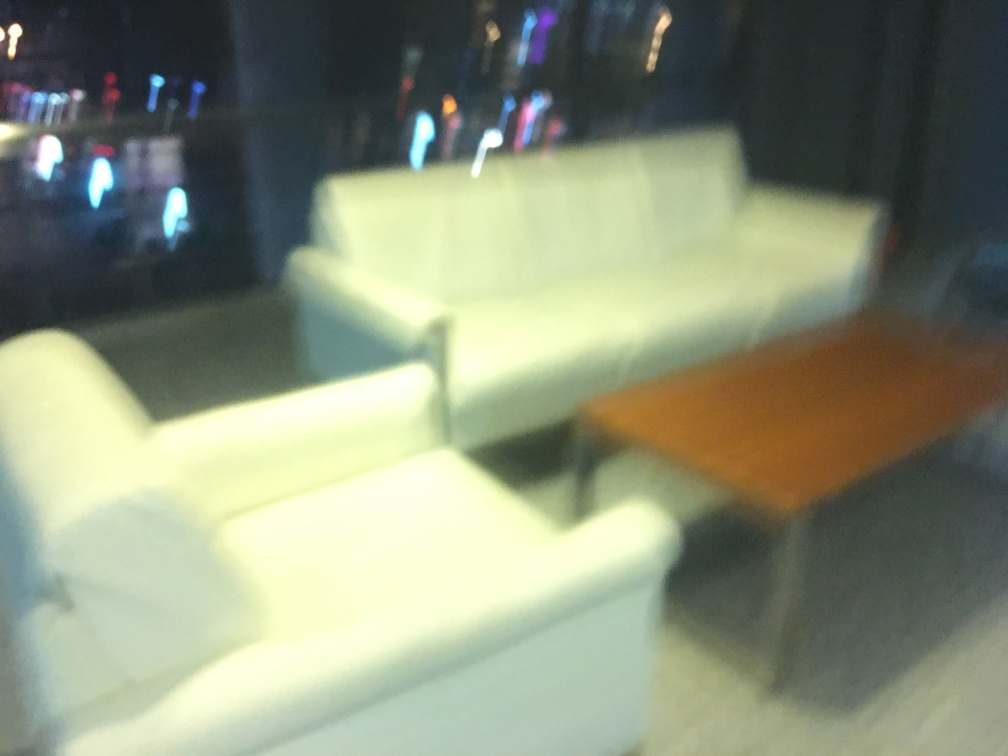What kind of setting does this image suggest? While the image lacks clarity due to blurriness, it suggests an indoor setting, possibly a room with furniture such as a sofa and a table. The blurred lights in the background could indicate that this space is near a window overlooking an illuminated outdoor area, like a cityscape at night. Could this image be used in its current state for any purpose? Despite the poor sharpness, this image may still have aesthetic value in contexts that embrace a dreamlike or abstract representation, such as in art projects or backgrounds where a clear depiction isn't necessary. However, for most conventional uses that require image clarity, this photo would likely need retaking or substantial editing. 